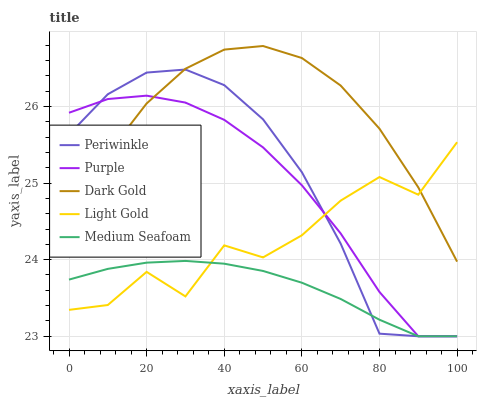Does Medium Seafoam have the minimum area under the curve?
Answer yes or no. Yes. Does Dark Gold have the maximum area under the curve?
Answer yes or no. Yes. Does Light Gold have the minimum area under the curve?
Answer yes or no. No. Does Light Gold have the maximum area under the curve?
Answer yes or no. No. Is Medium Seafoam the smoothest?
Answer yes or no. Yes. Is Light Gold the roughest?
Answer yes or no. Yes. Is Periwinkle the smoothest?
Answer yes or no. No. Is Periwinkle the roughest?
Answer yes or no. No. Does Purple have the lowest value?
Answer yes or no. Yes. Does Light Gold have the lowest value?
Answer yes or no. No. Does Dark Gold have the highest value?
Answer yes or no. Yes. Does Light Gold have the highest value?
Answer yes or no. No. Is Medium Seafoam less than Dark Gold?
Answer yes or no. Yes. Is Dark Gold greater than Medium Seafoam?
Answer yes or no. Yes. Does Medium Seafoam intersect Light Gold?
Answer yes or no. Yes. Is Medium Seafoam less than Light Gold?
Answer yes or no. No. Is Medium Seafoam greater than Light Gold?
Answer yes or no. No. Does Medium Seafoam intersect Dark Gold?
Answer yes or no. No. 